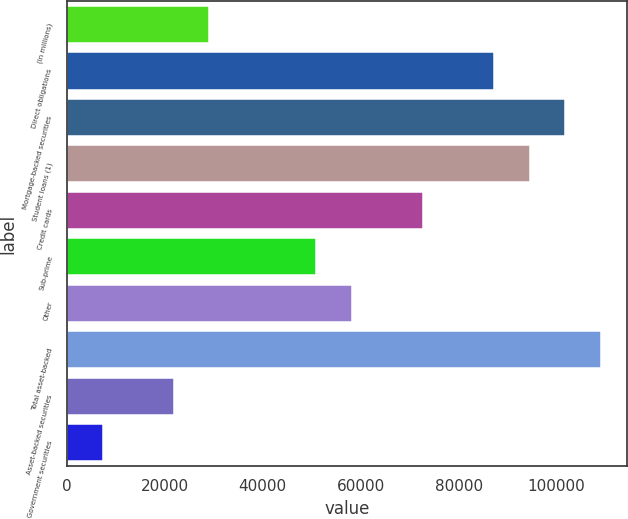Convert chart to OTSL. <chart><loc_0><loc_0><loc_500><loc_500><bar_chart><fcel>(In millions)<fcel>Direct obligations<fcel>Mortgage-backed securities<fcel>Student loans (1)<fcel>Credit cards<fcel>Sub-prime<fcel>Other<fcel>Total asset-backed<fcel>Asset-backed securities<fcel>Government securities<nl><fcel>29129.4<fcel>87222.2<fcel>101745<fcel>94483.8<fcel>72699<fcel>50914.2<fcel>58175.8<fcel>109007<fcel>21867.8<fcel>7344.6<nl></chart> 